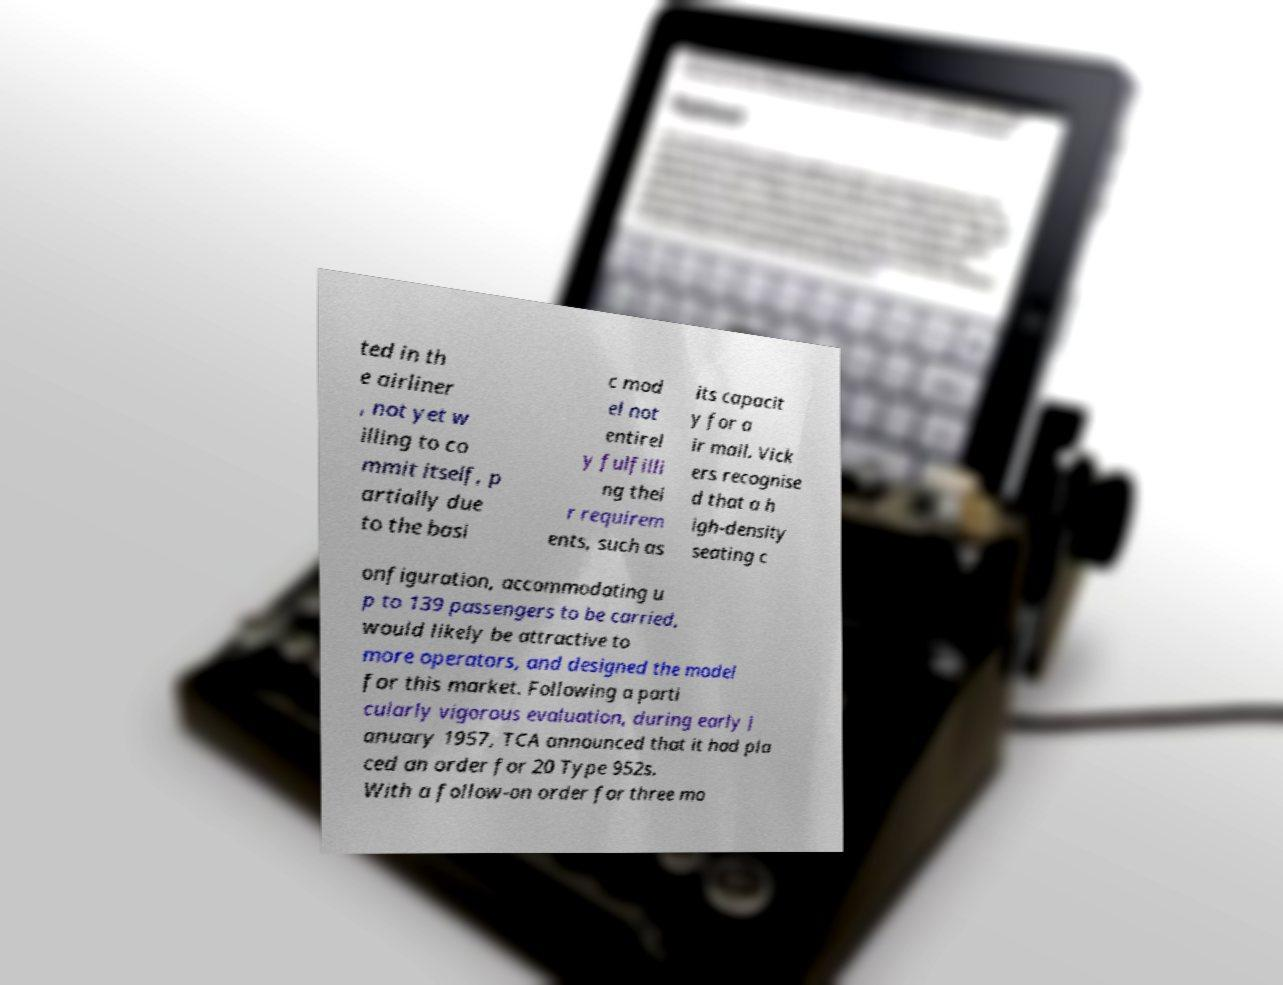There's text embedded in this image that I need extracted. Can you transcribe it verbatim? ted in th e airliner , not yet w illing to co mmit itself, p artially due to the basi c mod el not entirel y fulfilli ng thei r requirem ents, such as its capacit y for a ir mail. Vick ers recognise d that a h igh-density seating c onfiguration, accommodating u p to 139 passengers to be carried, would likely be attractive to more operators, and designed the model for this market. Following a parti cularly vigorous evaluation, during early J anuary 1957, TCA announced that it had pla ced an order for 20 Type 952s. With a follow-on order for three mo 